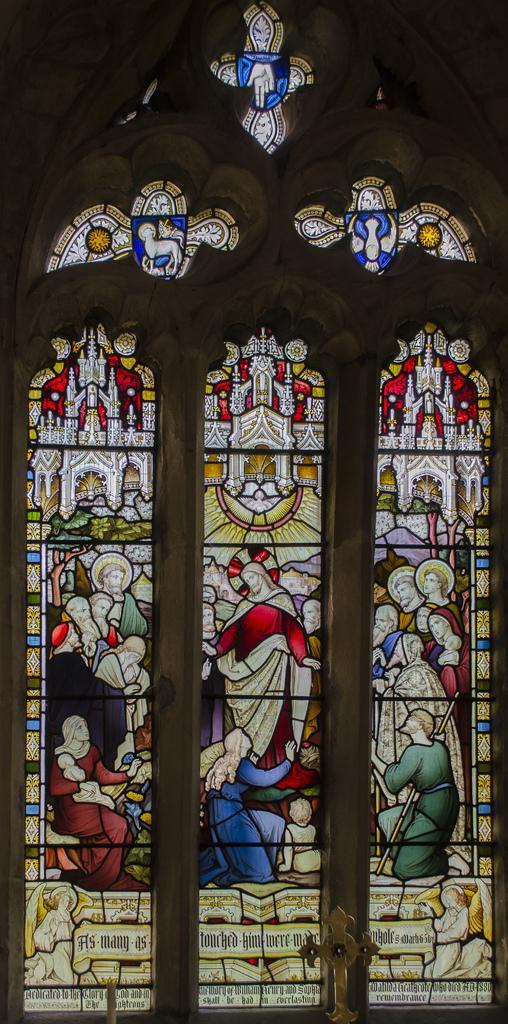Can you describe this image briefly? In this picture we can see windows, on these windows we can see people, symbols and some text on it. 